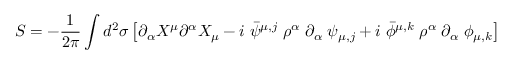Convert formula to latex. <formula><loc_0><loc_0><loc_500><loc_500>S = - \frac { 1 } { 2 \pi } \int d ^ { 2 } \sigma \left [ \partial _ { \alpha } X ^ { \mu } \partial ^ { \alpha } X _ { \mu } - i \, \bar { \psi } ^ { \mu , j } \, \rho ^ { \alpha } \, \partial _ { \alpha } \, \psi _ { \mu , j } + i \, \bar { \phi } ^ { \mu , k } \, \rho ^ { \alpha } \, \partial _ { \alpha } \, \phi _ { \mu , k } \right ]</formula> 